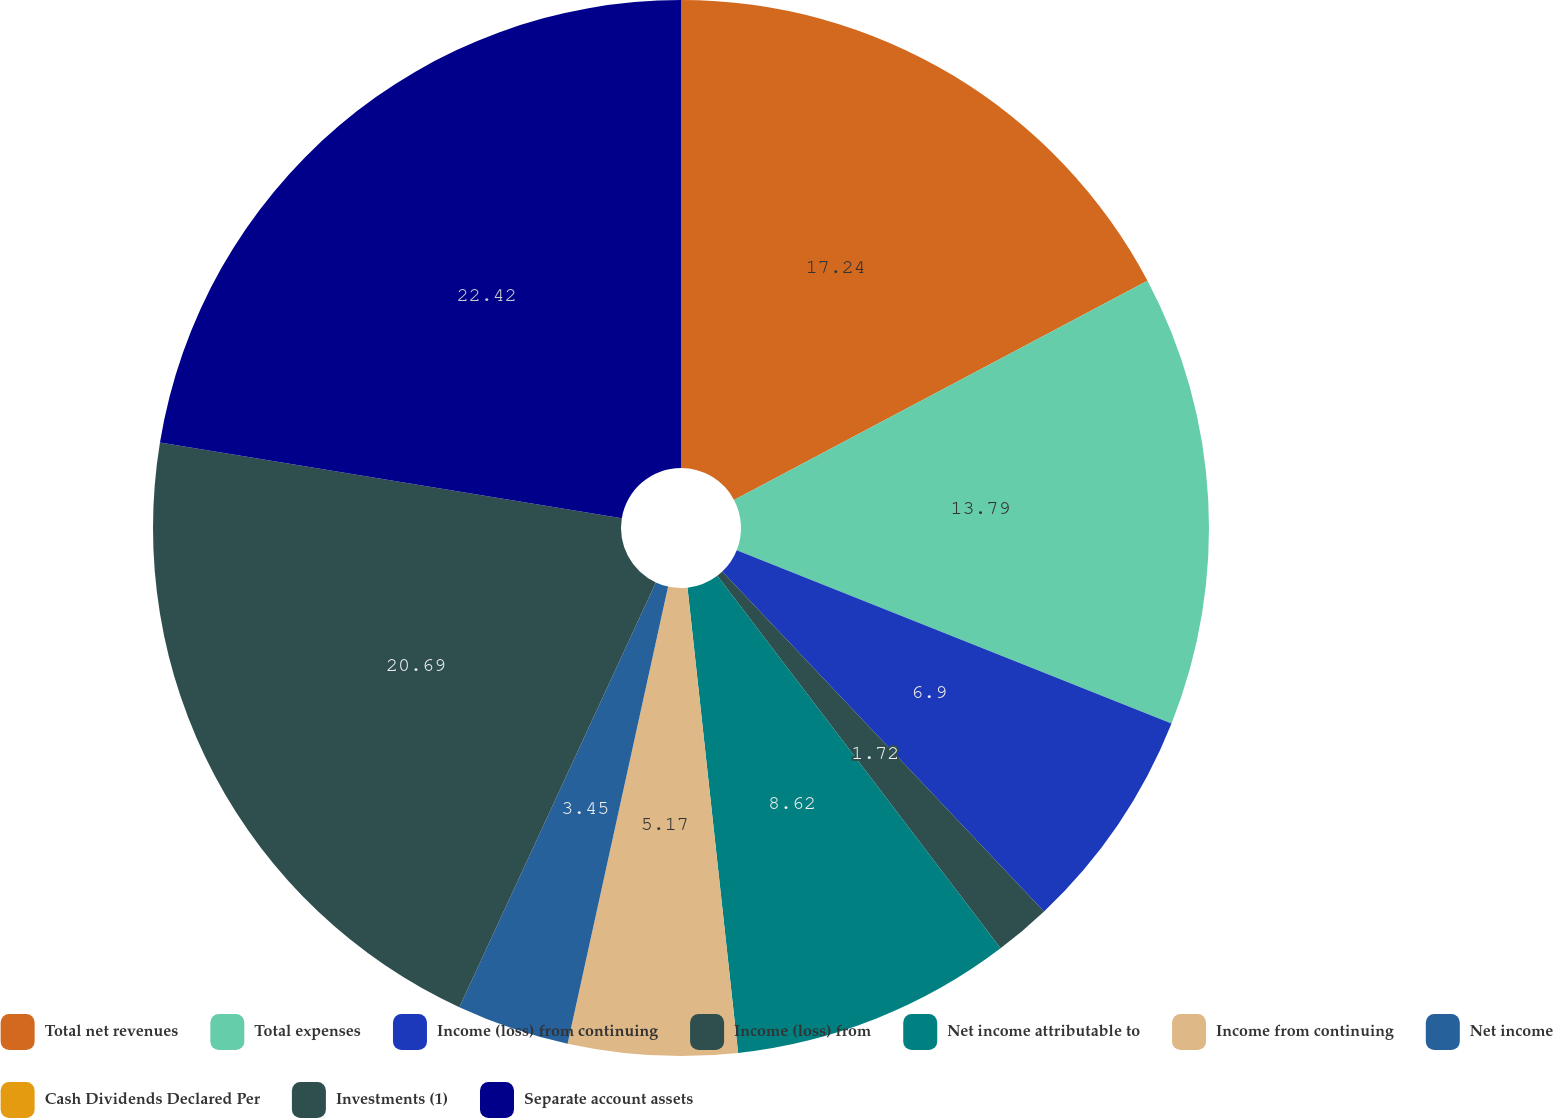Convert chart to OTSL. <chart><loc_0><loc_0><loc_500><loc_500><pie_chart><fcel>Total net revenues<fcel>Total expenses<fcel>Income (loss) from continuing<fcel>Income (loss) from<fcel>Net income attributable to<fcel>Income from continuing<fcel>Net income<fcel>Cash Dividends Declared Per<fcel>Investments (1)<fcel>Separate account assets<nl><fcel>17.24%<fcel>13.79%<fcel>6.9%<fcel>1.72%<fcel>8.62%<fcel>5.17%<fcel>3.45%<fcel>0.0%<fcel>20.69%<fcel>22.41%<nl></chart> 